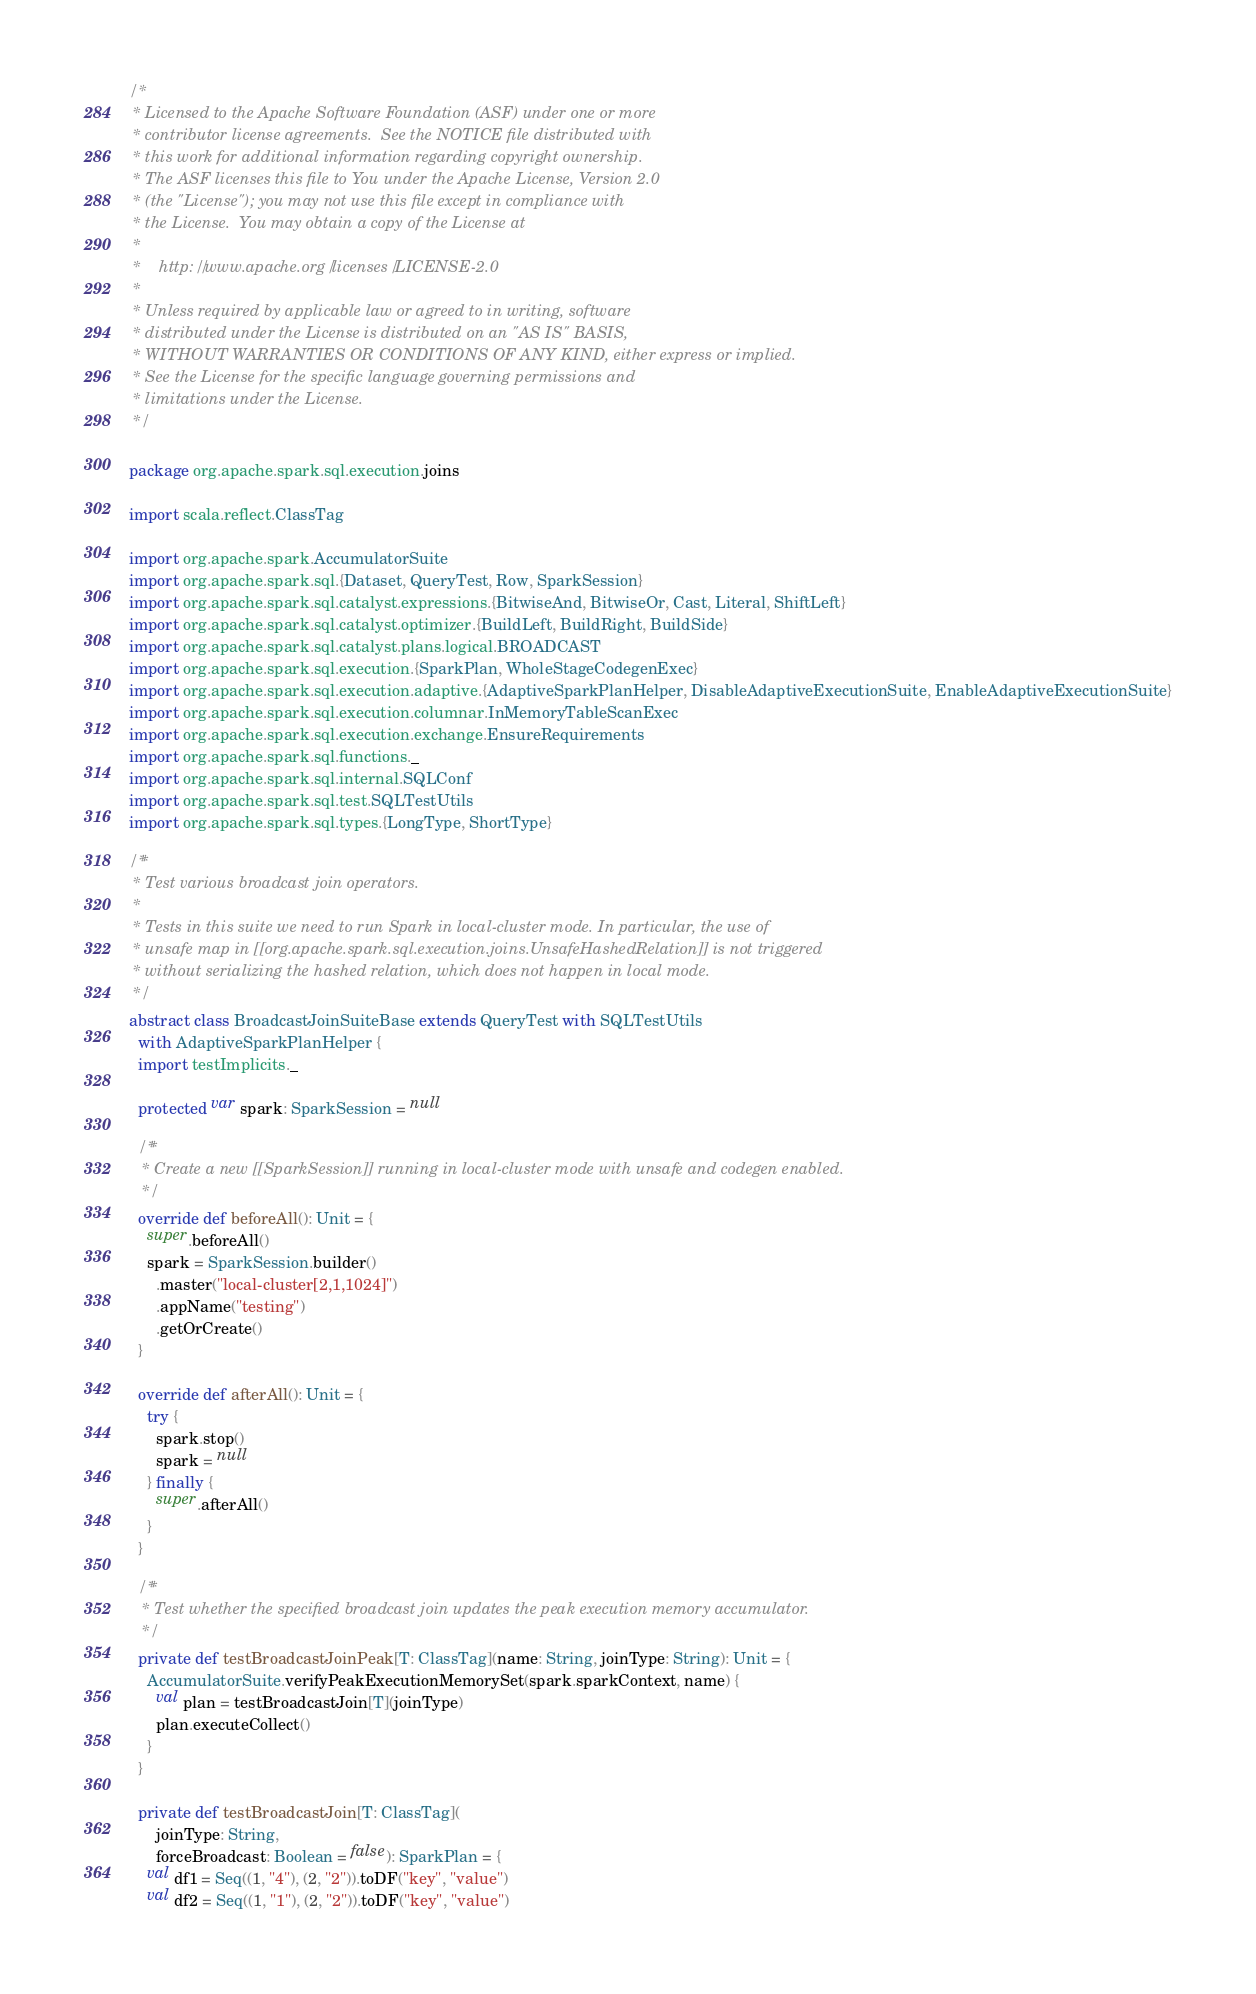Convert code to text. <code><loc_0><loc_0><loc_500><loc_500><_Scala_>/*
 * Licensed to the Apache Software Foundation (ASF) under one or more
 * contributor license agreements.  See the NOTICE file distributed with
 * this work for additional information regarding copyright ownership.
 * The ASF licenses this file to You under the Apache License, Version 2.0
 * (the "License"); you may not use this file except in compliance with
 * the License.  You may obtain a copy of the License at
 *
 *    http://www.apache.org/licenses/LICENSE-2.0
 *
 * Unless required by applicable law or agreed to in writing, software
 * distributed under the License is distributed on an "AS IS" BASIS,
 * WITHOUT WARRANTIES OR CONDITIONS OF ANY KIND, either express or implied.
 * See the License for the specific language governing permissions and
 * limitations under the License.
 */

package org.apache.spark.sql.execution.joins

import scala.reflect.ClassTag

import org.apache.spark.AccumulatorSuite
import org.apache.spark.sql.{Dataset, QueryTest, Row, SparkSession}
import org.apache.spark.sql.catalyst.expressions.{BitwiseAnd, BitwiseOr, Cast, Literal, ShiftLeft}
import org.apache.spark.sql.catalyst.optimizer.{BuildLeft, BuildRight, BuildSide}
import org.apache.spark.sql.catalyst.plans.logical.BROADCAST
import org.apache.spark.sql.execution.{SparkPlan, WholeStageCodegenExec}
import org.apache.spark.sql.execution.adaptive.{AdaptiveSparkPlanHelper, DisableAdaptiveExecutionSuite, EnableAdaptiveExecutionSuite}
import org.apache.spark.sql.execution.columnar.InMemoryTableScanExec
import org.apache.spark.sql.execution.exchange.EnsureRequirements
import org.apache.spark.sql.functions._
import org.apache.spark.sql.internal.SQLConf
import org.apache.spark.sql.test.SQLTestUtils
import org.apache.spark.sql.types.{LongType, ShortType}

/**
 * Test various broadcast join operators.
 *
 * Tests in this suite we need to run Spark in local-cluster mode. In particular, the use of
 * unsafe map in [[org.apache.spark.sql.execution.joins.UnsafeHashedRelation]] is not triggered
 * without serializing the hashed relation, which does not happen in local mode.
 */
abstract class BroadcastJoinSuiteBase extends QueryTest with SQLTestUtils
  with AdaptiveSparkPlanHelper {
  import testImplicits._

  protected var spark: SparkSession = null

  /**
   * Create a new [[SparkSession]] running in local-cluster mode with unsafe and codegen enabled.
   */
  override def beforeAll(): Unit = {
    super.beforeAll()
    spark = SparkSession.builder()
      .master("local-cluster[2,1,1024]")
      .appName("testing")
      .getOrCreate()
  }

  override def afterAll(): Unit = {
    try {
      spark.stop()
      spark = null
    } finally {
      super.afterAll()
    }
  }

  /**
   * Test whether the specified broadcast join updates the peak execution memory accumulator.
   */
  private def testBroadcastJoinPeak[T: ClassTag](name: String, joinType: String): Unit = {
    AccumulatorSuite.verifyPeakExecutionMemorySet(spark.sparkContext, name) {
      val plan = testBroadcastJoin[T](joinType)
      plan.executeCollect()
    }
  }

  private def testBroadcastJoin[T: ClassTag](
      joinType: String,
      forceBroadcast: Boolean = false): SparkPlan = {
    val df1 = Seq((1, "4"), (2, "2")).toDF("key", "value")
    val df2 = Seq((1, "1"), (2, "2")).toDF("key", "value")
</code> 